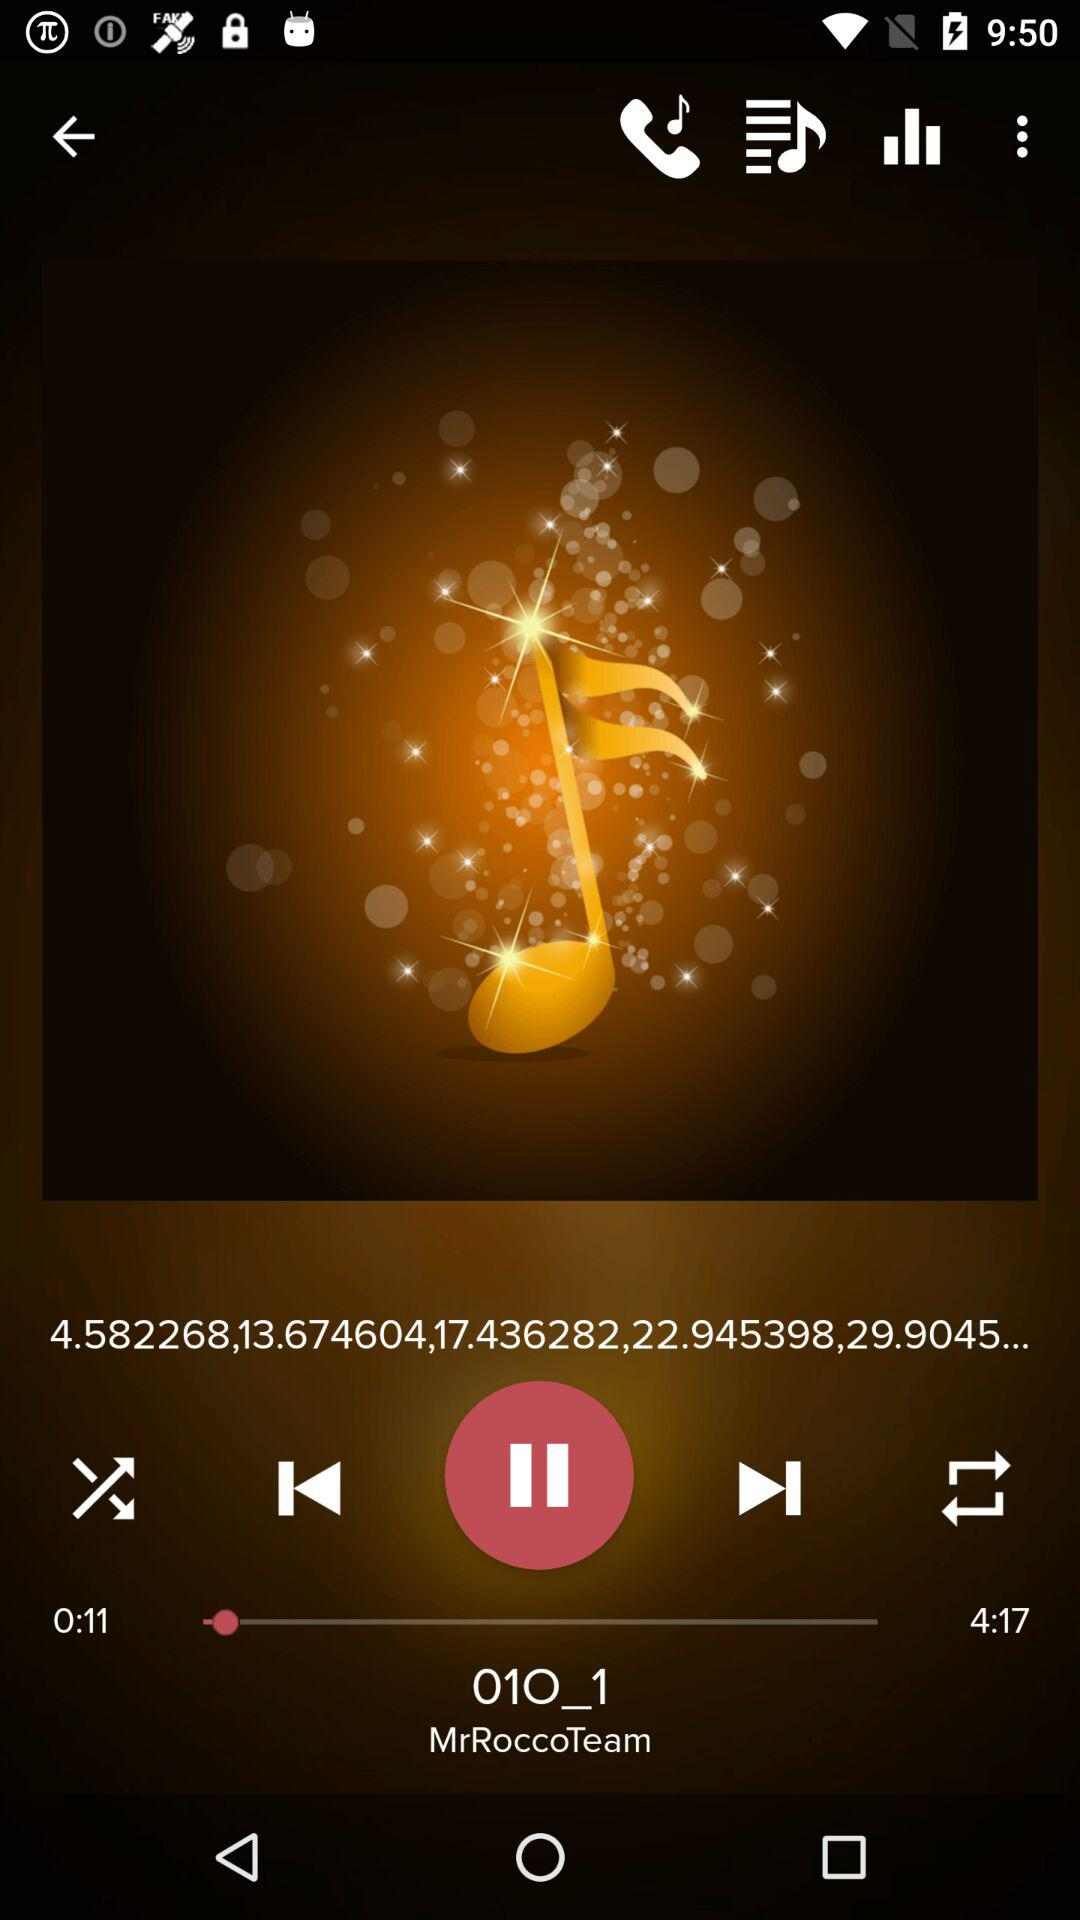What is the name of the audio? The name of the audio is "01O_1". 